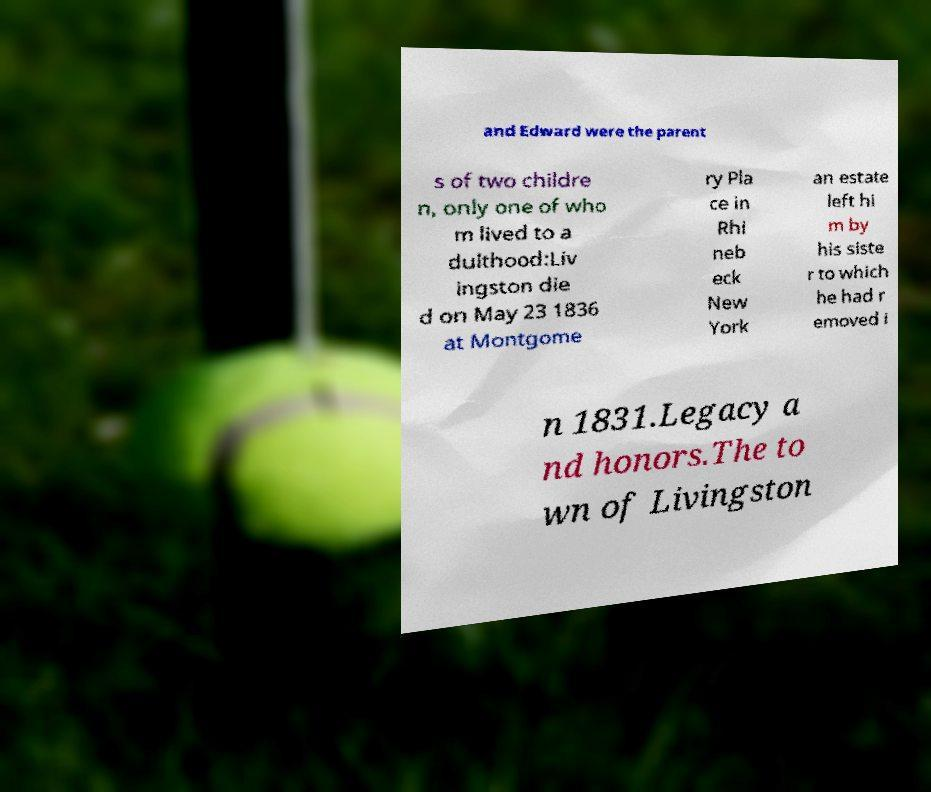Could you assist in decoding the text presented in this image and type it out clearly? and Edward were the parent s of two childre n, only one of who m lived to a dulthood:Liv ingston die d on May 23 1836 at Montgome ry Pla ce in Rhi neb eck New York an estate left hi m by his siste r to which he had r emoved i n 1831.Legacy a nd honors.The to wn of Livingston 